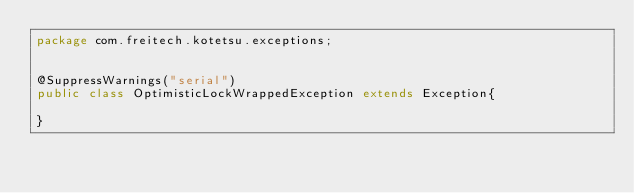Convert code to text. <code><loc_0><loc_0><loc_500><loc_500><_Java_>package com.freitech.kotetsu.exceptions;


@SuppressWarnings("serial")
public class OptimisticLockWrappedException extends Exception{

}
</code> 